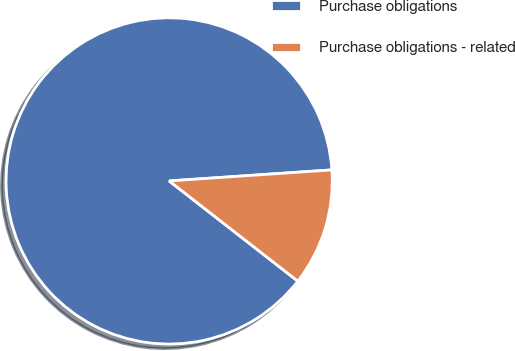<chart> <loc_0><loc_0><loc_500><loc_500><pie_chart><fcel>Purchase obligations<fcel>Purchase obligations - related<nl><fcel>88.39%<fcel>11.61%<nl></chart> 